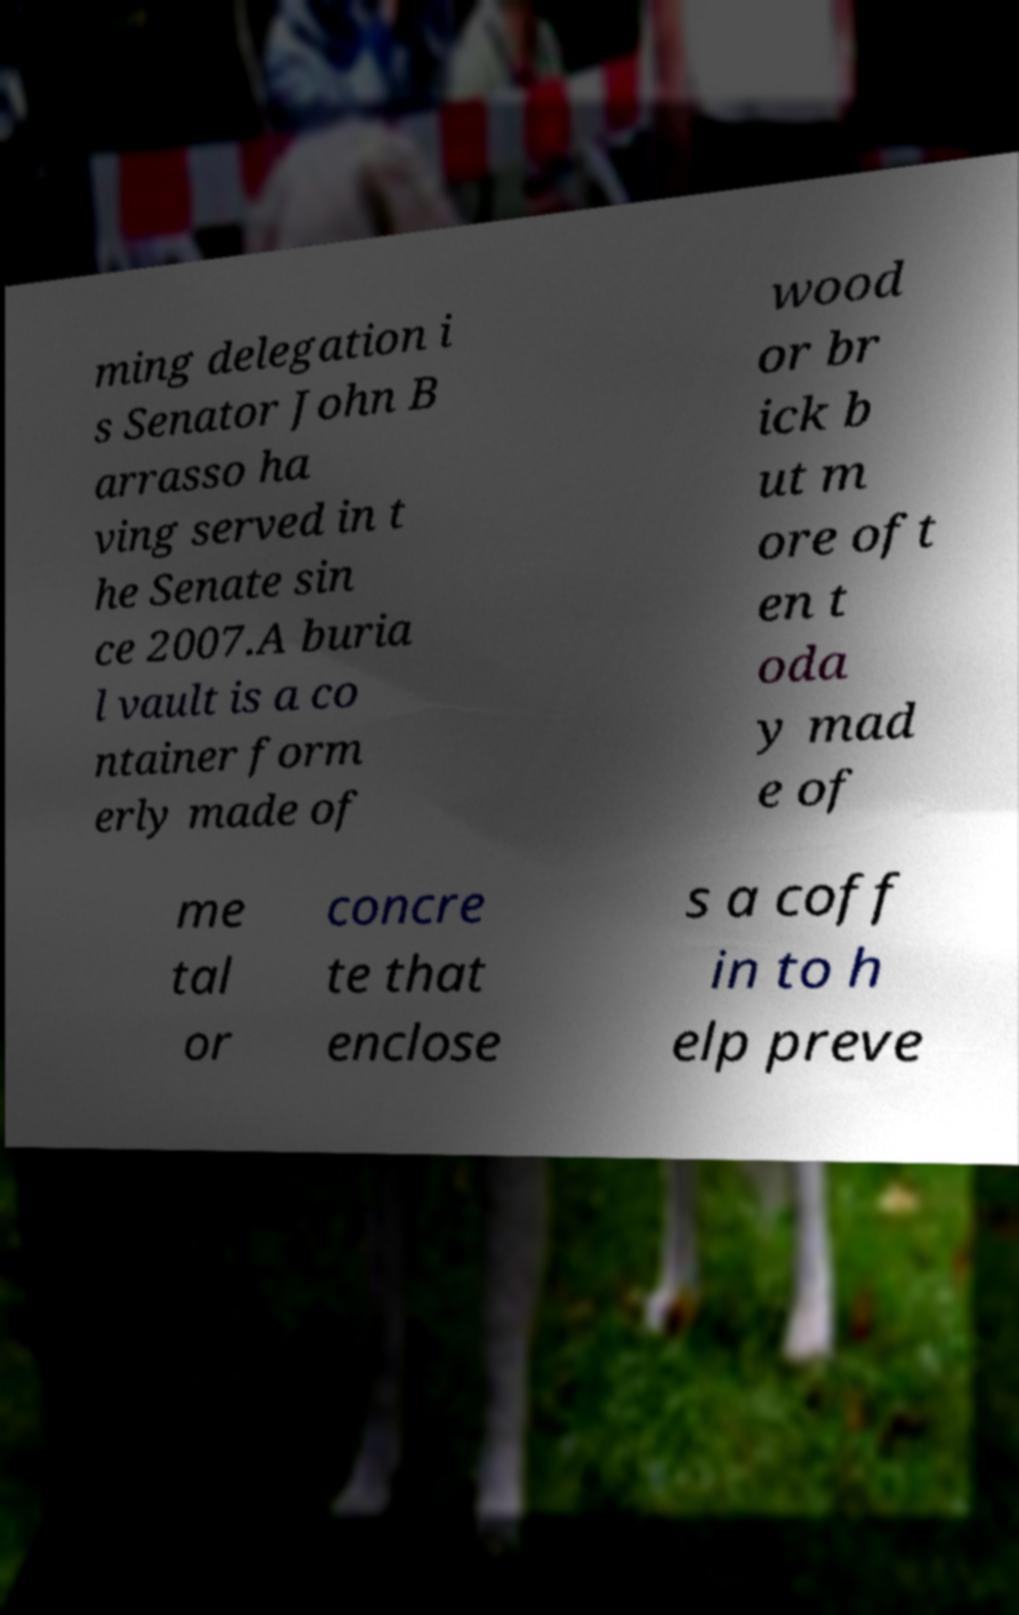Can you accurately transcribe the text from the provided image for me? ming delegation i s Senator John B arrasso ha ving served in t he Senate sin ce 2007.A buria l vault is a co ntainer form erly made of wood or br ick b ut m ore oft en t oda y mad e of me tal or concre te that enclose s a coff in to h elp preve 